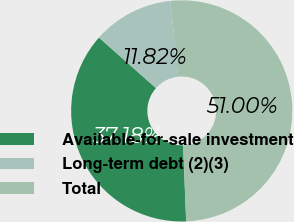Convert chart to OTSL. <chart><loc_0><loc_0><loc_500><loc_500><pie_chart><fcel>Available-for-sale investment<fcel>Long-term debt (2)(3)<fcel>Total<nl><fcel>37.18%<fcel>11.82%<fcel>51.0%<nl></chart> 